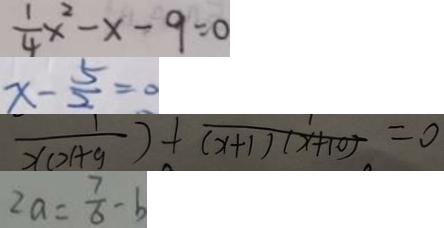<formula> <loc_0><loc_0><loc_500><loc_500>\frac { 1 } { 4 } x ^ { 2 } - x - 9 = 0 
 x - \frac { 5 } { 2 } = 0 
 \frac { 1 } { x ( x + y ) } + \frac { 1 } { ( x + 1 ) ( x + 1 0 ) } = 0 
 2 a = \frac { 7 } { 6 } - b</formula> 